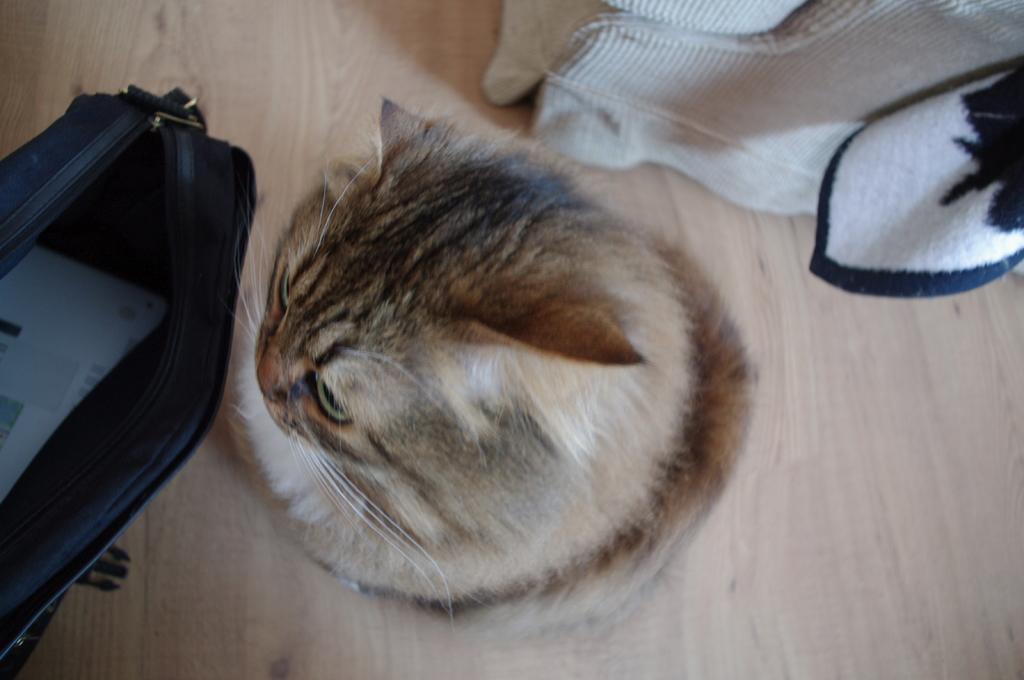Can you describe this image briefly? In this image we can see a cat on the floor and cloth behind the cat and a bag with a paper in the bag in front of the cat. 